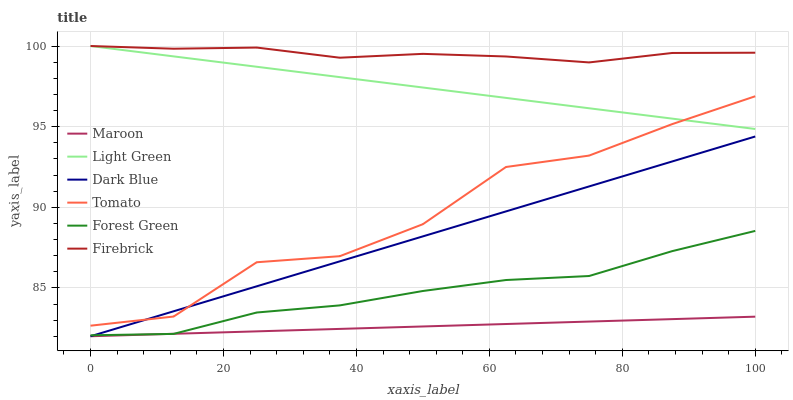Does Firebrick have the minimum area under the curve?
Answer yes or no. No. Does Maroon have the maximum area under the curve?
Answer yes or no. No. Is Firebrick the smoothest?
Answer yes or no. No. Is Firebrick the roughest?
Answer yes or no. No. Does Firebrick have the lowest value?
Answer yes or no. No. Does Maroon have the highest value?
Answer yes or no. No. Is Forest Green less than Firebrick?
Answer yes or no. Yes. Is Light Green greater than Forest Green?
Answer yes or no. Yes. Does Forest Green intersect Firebrick?
Answer yes or no. No. 